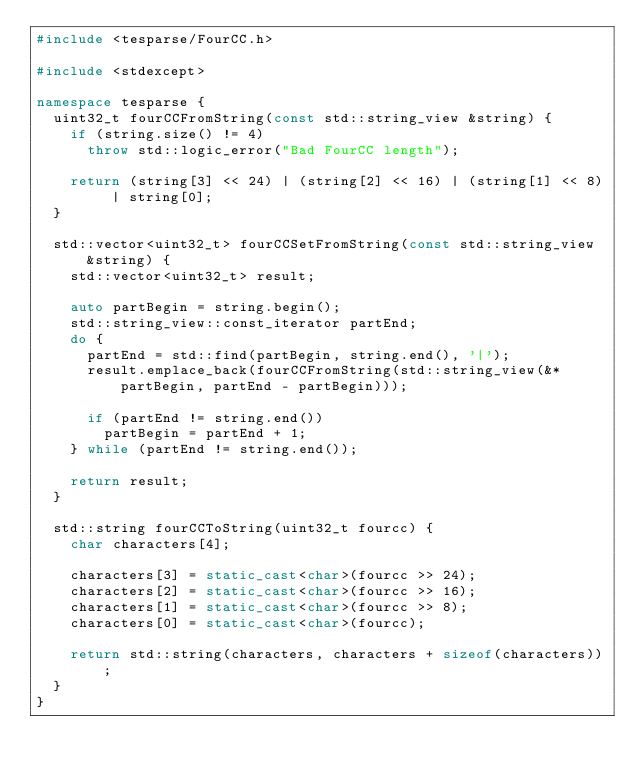Convert code to text. <code><loc_0><loc_0><loc_500><loc_500><_C++_>#include <tesparse/FourCC.h>

#include <stdexcept>

namespace tesparse {
	uint32_t fourCCFromString(const std::string_view &string) {
		if (string.size() != 4)
			throw std::logic_error("Bad FourCC length");

		return (string[3] << 24) | (string[2] << 16) | (string[1] << 8) | string[0];
	}

	std::vector<uint32_t> fourCCSetFromString(const std::string_view &string) {
		std::vector<uint32_t> result;

		auto partBegin = string.begin();
		std::string_view::const_iterator partEnd;
		do {
			partEnd = std::find(partBegin, string.end(), '|');
			result.emplace_back(fourCCFromString(std::string_view(&*partBegin, partEnd - partBegin)));

			if (partEnd != string.end())
				partBegin = partEnd + 1;
		} while (partEnd != string.end());

		return result;
	}

	std::string fourCCToString(uint32_t fourcc) {
		char characters[4];

		characters[3] = static_cast<char>(fourcc >> 24);
		characters[2] = static_cast<char>(fourcc >> 16);
		characters[1] = static_cast<char>(fourcc >> 8);
		characters[0] = static_cast<char>(fourcc);

		return std::string(characters, characters + sizeof(characters));
	}
}
</code> 